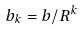<formula> <loc_0><loc_0><loc_500><loc_500>b _ { k } = b / R ^ { k }</formula> 